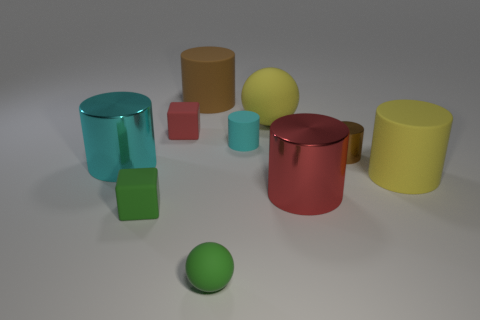Which objects in this image share the same glossy finish? The red cylindrical canister and the yellow cylindrical canister share the same glossy finish. 